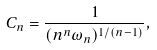Convert formula to latex. <formula><loc_0><loc_0><loc_500><loc_500>C _ { n } = \frac { 1 } { ( n ^ { n } \omega _ { n } ) ^ { 1 / ( n - 1 ) } } ,</formula> 